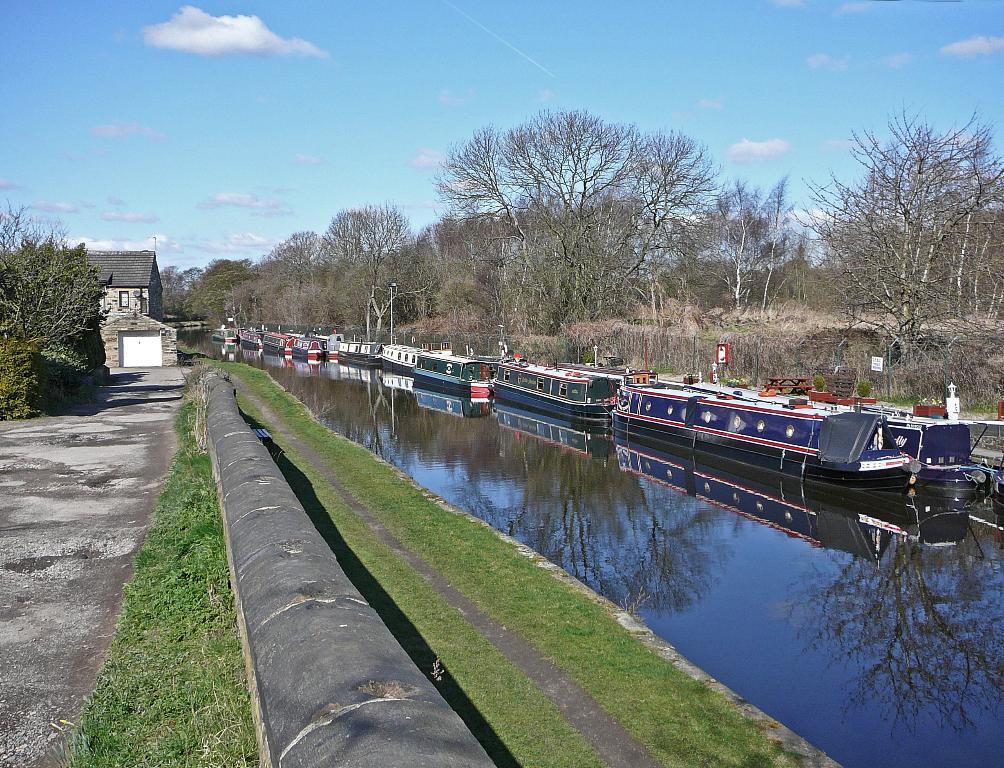In one or two sentences, can you explain what this image depicts? In this image we can see few boats on the water, there are few trees, grass, building and the sky with clouds in the background. 